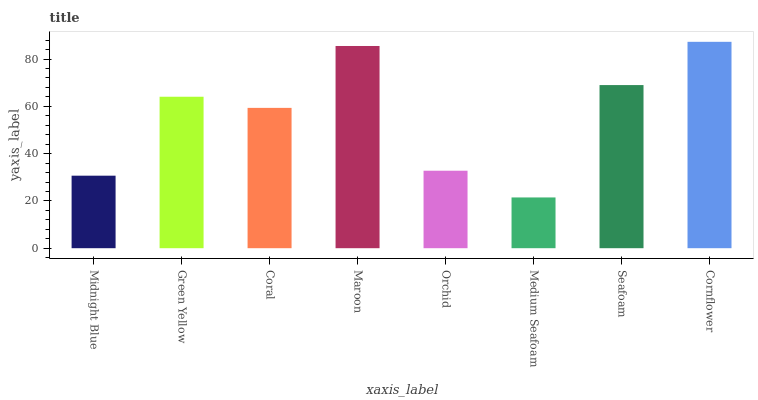Is Medium Seafoam the minimum?
Answer yes or no. Yes. Is Cornflower the maximum?
Answer yes or no. Yes. Is Green Yellow the minimum?
Answer yes or no. No. Is Green Yellow the maximum?
Answer yes or no. No. Is Green Yellow greater than Midnight Blue?
Answer yes or no. Yes. Is Midnight Blue less than Green Yellow?
Answer yes or no. Yes. Is Midnight Blue greater than Green Yellow?
Answer yes or no. No. Is Green Yellow less than Midnight Blue?
Answer yes or no. No. Is Green Yellow the high median?
Answer yes or no. Yes. Is Coral the low median?
Answer yes or no. Yes. Is Orchid the high median?
Answer yes or no. No. Is Green Yellow the low median?
Answer yes or no. No. 